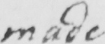Please transcribe the handwritten text in this image. made 